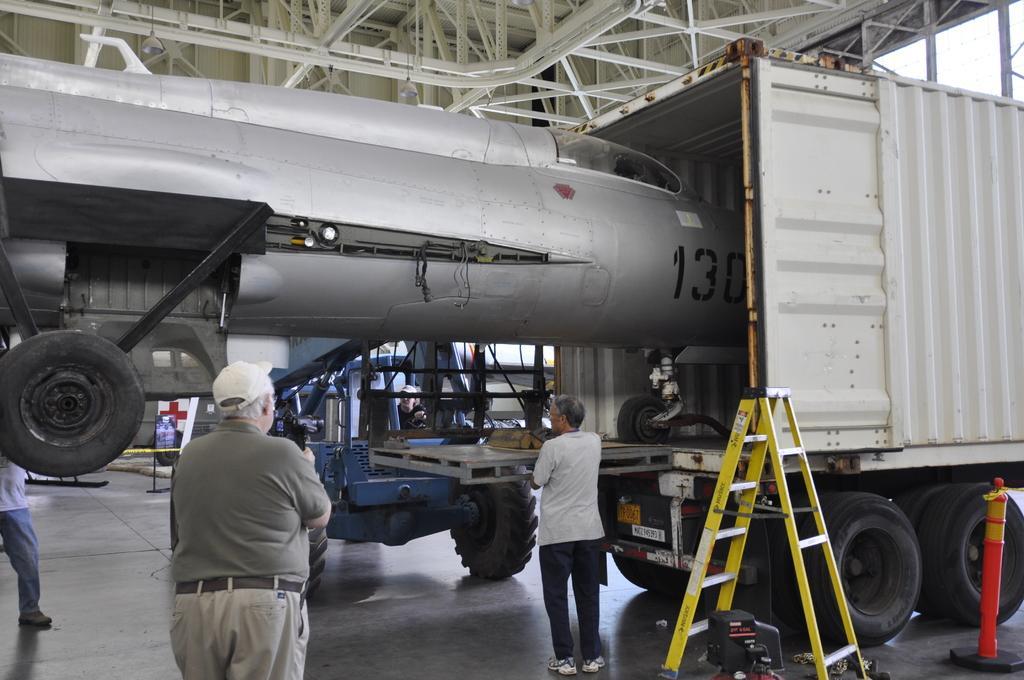In one or two sentences, can you explain what this image depicts? This image is taken indoors. At the bottom of the image there is a floor. At the top of the image there is a roof and there are many iron bars. In the middle of the image a truck is parked on the floor. There is a ladder and there are a few objects on the floor. There is an airplane and there is another vehicle parked on the floor. A few people are standing on the floor. 